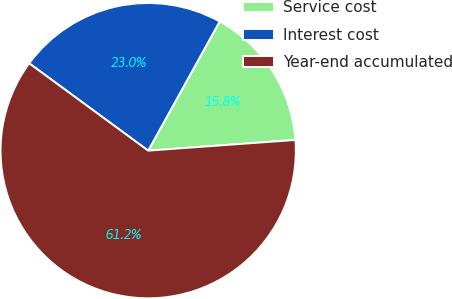Convert chart to OTSL. <chart><loc_0><loc_0><loc_500><loc_500><pie_chart><fcel>Service cost<fcel>Interest cost<fcel>Year-end accumulated<nl><fcel>15.8%<fcel>22.97%<fcel>61.23%<nl></chart> 